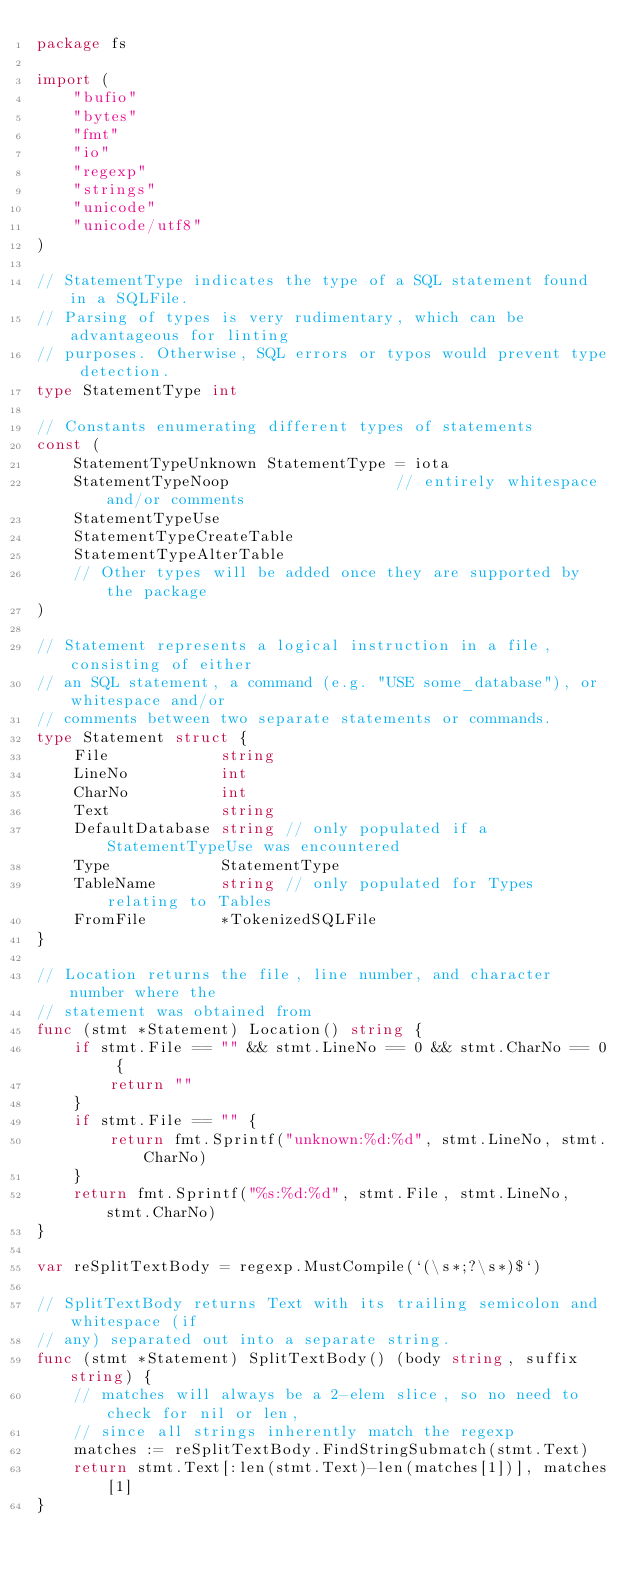Convert code to text. <code><loc_0><loc_0><loc_500><loc_500><_Go_>package fs

import (
	"bufio"
	"bytes"
	"fmt"
	"io"
	"regexp"
	"strings"
	"unicode"
	"unicode/utf8"
)

// StatementType indicates the type of a SQL statement found in a SQLFile.
// Parsing of types is very rudimentary, which can be advantageous for linting
// purposes. Otherwise, SQL errors or typos would prevent type detection.
type StatementType int

// Constants enumerating different types of statements
const (
	StatementTypeUnknown StatementType = iota
	StatementTypeNoop                  // entirely whitespace and/or comments
	StatementTypeUse
	StatementTypeCreateTable
	StatementTypeAlterTable
	// Other types will be added once they are supported by the package
)

// Statement represents a logical instruction in a file, consisting of either
// an SQL statement, a command (e.g. "USE some_database"), or whitespace and/or
// comments between two separate statements or commands.
type Statement struct {
	File            string
	LineNo          int
	CharNo          int
	Text            string
	DefaultDatabase string // only populated if a StatementTypeUse was encountered
	Type            StatementType
	TableName       string // only populated for Types relating to Tables
	FromFile        *TokenizedSQLFile
}

// Location returns the file, line number, and character number where the
// statement was obtained from
func (stmt *Statement) Location() string {
	if stmt.File == "" && stmt.LineNo == 0 && stmt.CharNo == 0 {
		return ""
	}
	if stmt.File == "" {
		return fmt.Sprintf("unknown:%d:%d", stmt.LineNo, stmt.CharNo)
	}
	return fmt.Sprintf("%s:%d:%d", stmt.File, stmt.LineNo, stmt.CharNo)
}

var reSplitTextBody = regexp.MustCompile(`(\s*;?\s*)$`)

// SplitTextBody returns Text with its trailing semicolon and whitespace (if
// any) separated out into a separate string.
func (stmt *Statement) SplitTextBody() (body string, suffix string) {
	// matches will always be a 2-elem slice, so no need to check for nil or len,
	// since all strings inherently match the regexp
	matches := reSplitTextBody.FindStringSubmatch(stmt.Text)
	return stmt.Text[:len(stmt.Text)-len(matches[1])], matches[1]
}
</code> 